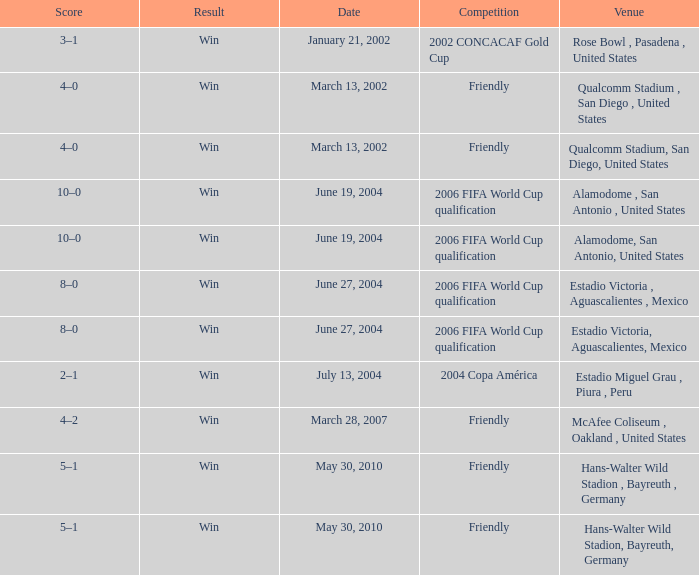What competition has June 19, 2004 as the date? 2006 FIFA World Cup qualification, 2006 FIFA World Cup qualification. 